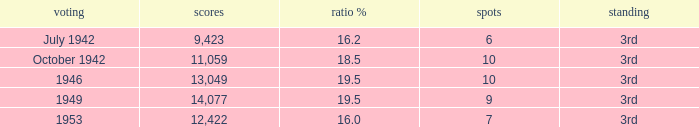Name the vote % for seats of 9 19.5. 